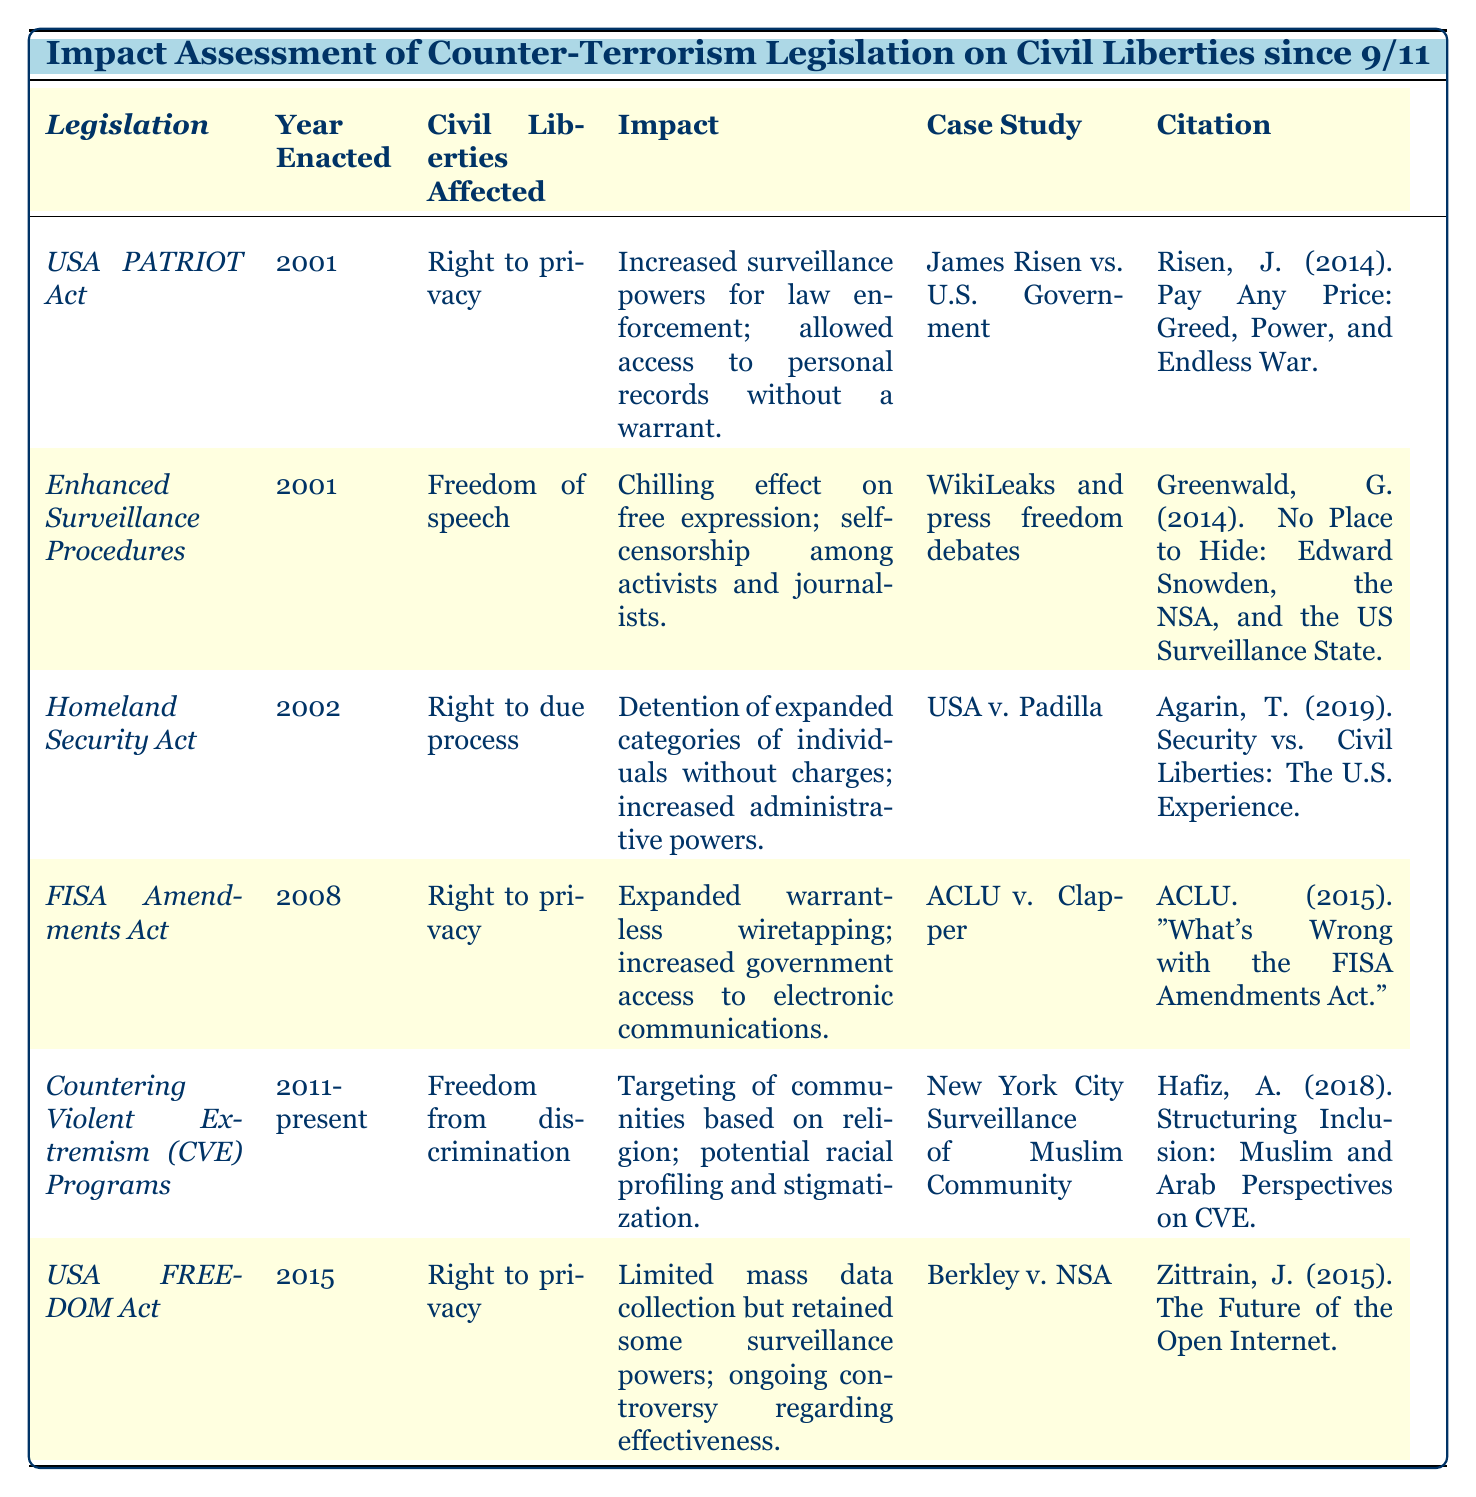What legislation was enacted in 2001 that affected the right to privacy? The table indicates that both the USA PATRIOT Act and Enhanced Surveillance Procedures were enacted in 2001. The USA PATRIOT Act specifically mentions the right to privacy as being affected.
Answer: USA PATRIOT Act Which year was the Homeland Security Act enacted? The table lists the year enacted for the Homeland Security Act as 2002, under the corresponding column.
Answer: 2002 What civil liberty is affected by the Countering Violent Extremism (CVE) Programs? The table shows that Freedom from discrimination is the civil liberty affected by the CVE Programs.
Answer: Freedom from discrimination How many legislations mention the right to privacy as a civil liberty affected? The table lists three legislations that mention the right to privacy: USA PATRIOT Act, FISA Amendments Act, and USA FREEDOM Act. So, the count is three.
Answer: 3 Did the USA FREEDOM Act completely eliminate mass data collection? According to the table, the USA FREEDOM Act limited mass data collection but did not completely eliminate some surveillance powers, indicating a "No."
Answer: No What is the impact associated with the Enhanced Surveillance Procedures? The table indicates that the Enhanced Surveillance Procedures have a chilling effect on free expression and lead to self-censorship among activists and journalists.
Answer: Chilling effect on free expression Which case study relates to the FISA Amendments Act? The table specifies that the case study for the FISA Amendments Act is ACLU v. Clapper.
Answer: ACLU v. Clapper What is the main concern regarding the impact of the USA PATRIOT Act? The table lists that the main concern regarding the USA PATRIOT Act is the increased surveillance powers for law enforcement and access to personal records without a warrant.
Answer: Increased surveillance powers How has the impact of the 2002 Homeland Security Act affected the right to due process? The table states that the Homeland Security Act led to the detention of expanded categories of individuals without charges and increased administrative powers, impacting the right to due process.
Answer: Detention without charges What common theme can be seen in the impact assessments of counter-terrorism legislation regarding civil liberties? The common theme in the impact assessments shown in the table reveals a trend where civil liberties, particularly privacy and freedom from discrimination, are repeatedly affected by various legislations.
Answer: Impact on civil liberties 